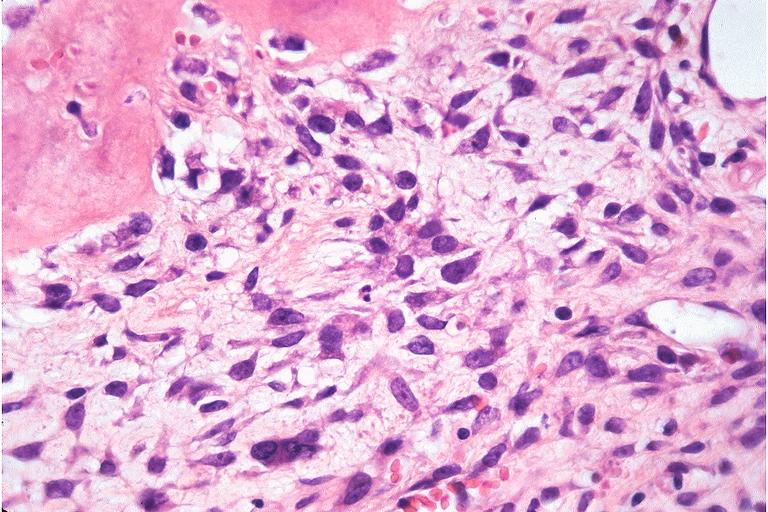s oral present?
Answer the question using a single word or phrase. Yes 